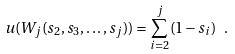Convert formula to latex. <formula><loc_0><loc_0><loc_500><loc_500>u ( W _ { j } ( s _ { 2 } , s _ { 3 } , \dots , s _ { j } ) ) = \sum _ { i = 2 } ^ { j } ( 1 - s _ { i } ) \ .</formula> 